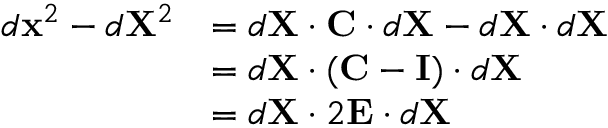<formula> <loc_0><loc_0><loc_500><loc_500>{ \begin{array} { r l } { d x ^ { 2 } - d X ^ { 2 } } & { = d X \cdot C \cdot d X - d X \cdot d X } \\ & { = d X \cdot ( C - I ) \cdot d X } \\ & { = d X \cdot 2 E \cdot d X } \end{array} }</formula> 